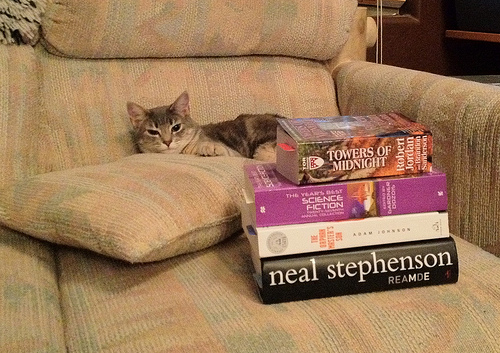<image>
Can you confirm if the cat is behind the book? Yes. From this viewpoint, the cat is positioned behind the book, with the book partially or fully occluding the cat. 